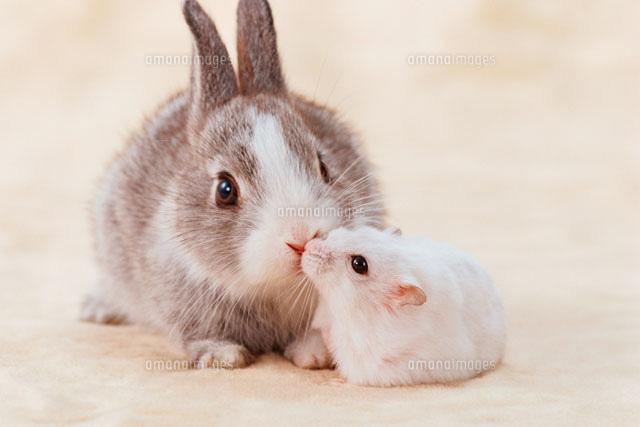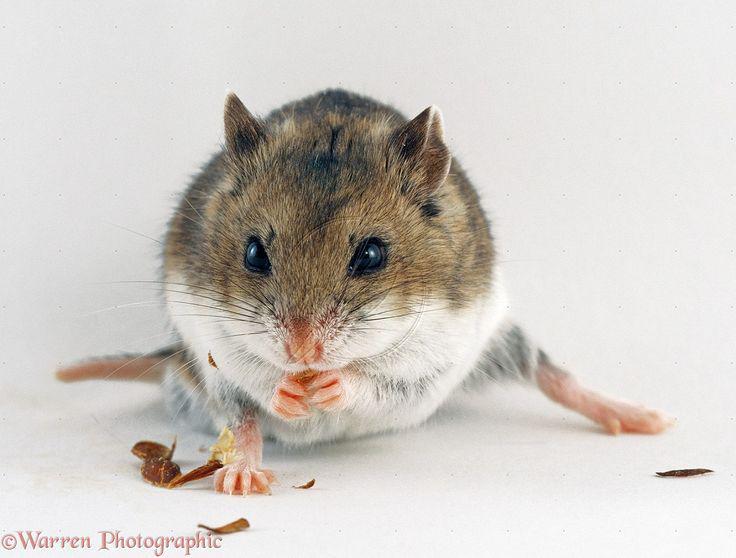The first image is the image on the left, the second image is the image on the right. Assess this claim about the two images: "Each image contains multiple pet rodents, and at least one image shows two rodents posed so one has its head directly above the other.". Correct or not? Answer yes or no. No. The first image is the image on the left, the second image is the image on the right. Examine the images to the left and right. Is the description "One rodent sits alone in the image on the right." accurate? Answer yes or no. Yes. 